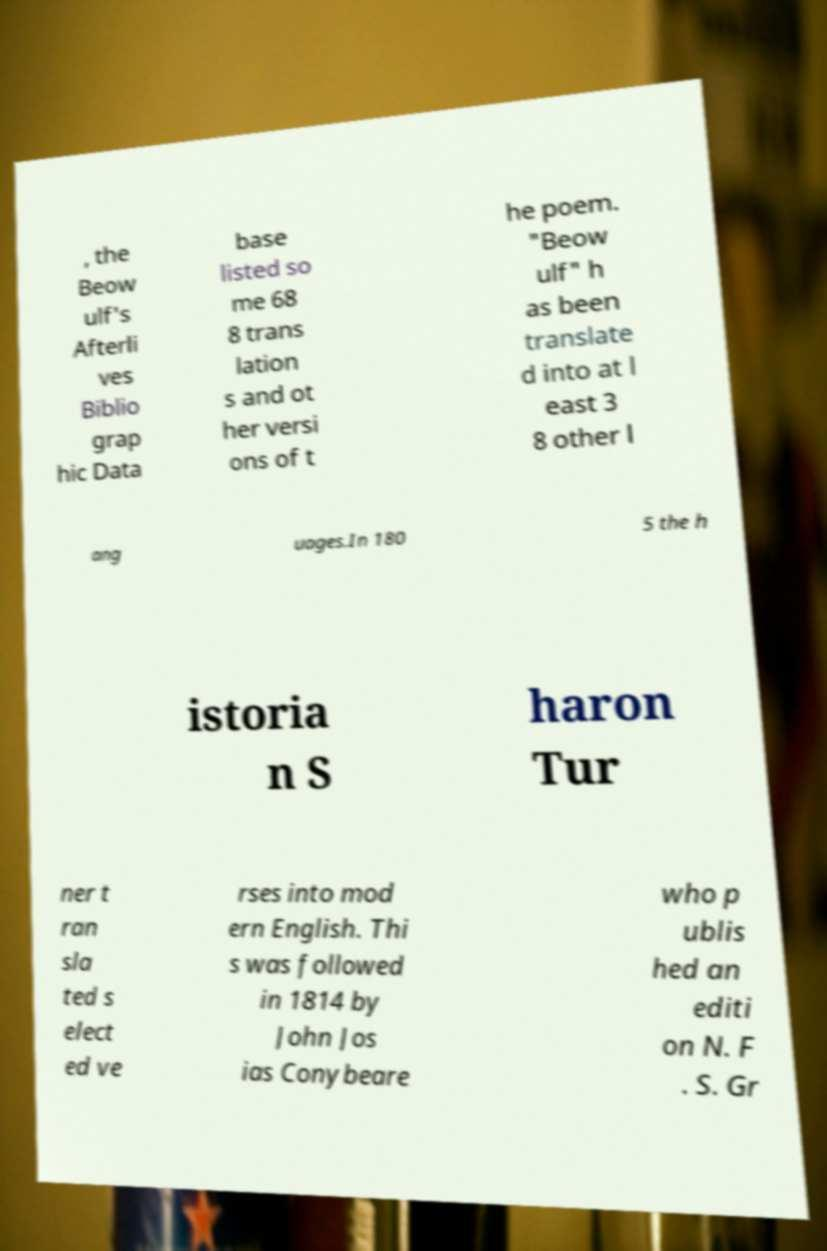I need the written content from this picture converted into text. Can you do that? , the Beow ulf's Afterli ves Biblio grap hic Data base listed so me 68 8 trans lation s and ot her versi ons of t he poem. "Beow ulf" h as been translate d into at l east 3 8 other l ang uages.In 180 5 the h istoria n S haron Tur ner t ran sla ted s elect ed ve rses into mod ern English. Thi s was followed in 1814 by John Jos ias Conybeare who p ublis hed an editi on N. F . S. Gr 